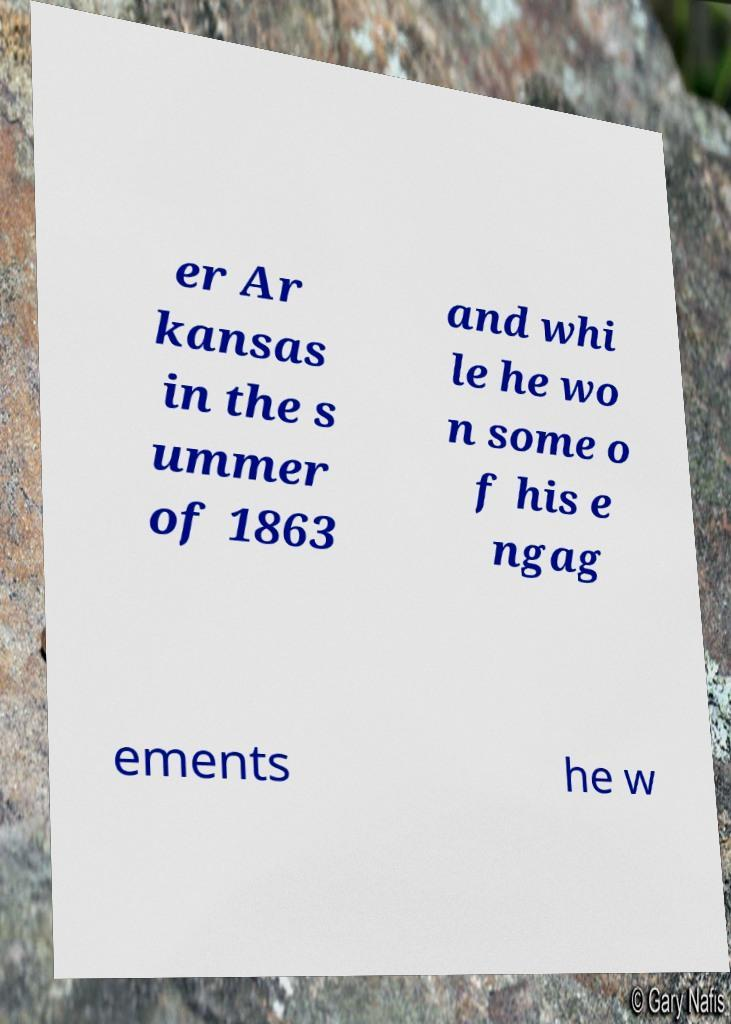Please identify and transcribe the text found in this image. er Ar kansas in the s ummer of 1863 and whi le he wo n some o f his e ngag ements he w 